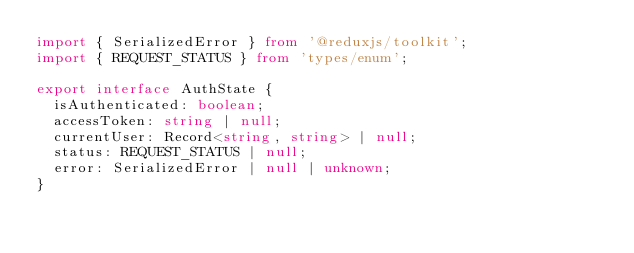<code> <loc_0><loc_0><loc_500><loc_500><_TypeScript_>import { SerializedError } from '@reduxjs/toolkit';
import { REQUEST_STATUS } from 'types/enum';

export interface AuthState {
  isAuthenticated: boolean;
  accessToken: string | null;
  currentUser: Record<string, string> | null;
  status: REQUEST_STATUS | null;
  error: SerializedError | null | unknown;
}
</code> 